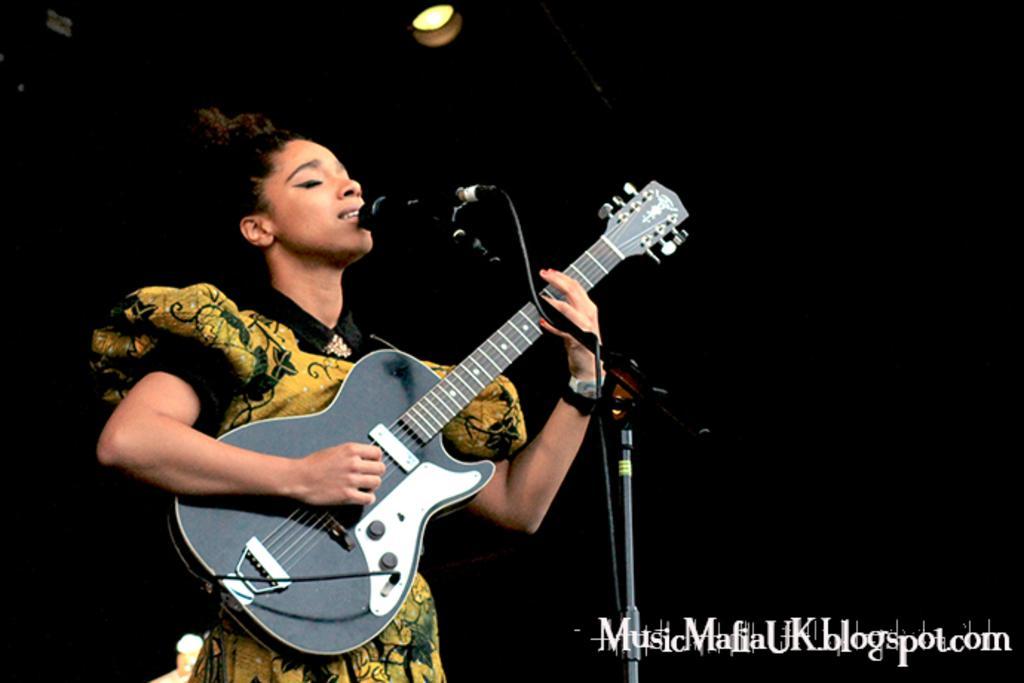How would you summarize this image in a sentence or two? It looks like a music show, a woman is holding guitar in her hand she is singing a song, the background is completely black. 